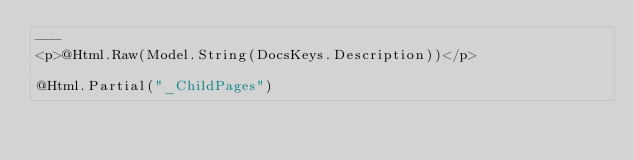Convert code to text. <code><loc_0><loc_0><loc_500><loc_500><_C#_>---
<p>@Html.Raw(Model.String(DocsKeys.Description))</p>

@Html.Partial("_ChildPages")</code> 